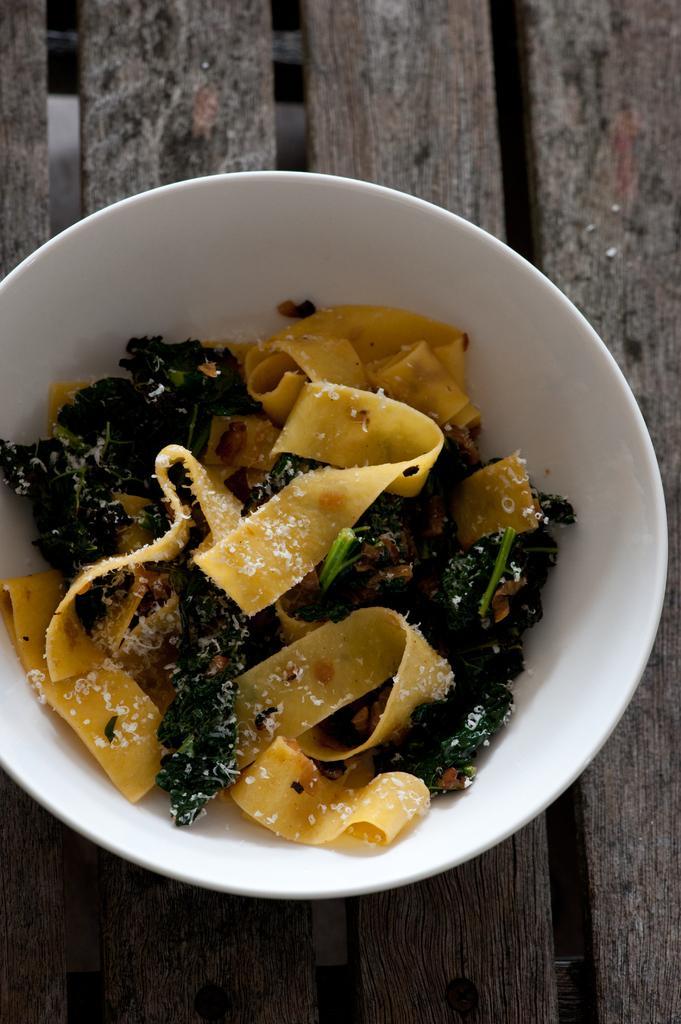Can you describe this image briefly? In this picture we can see food in the bowl. 